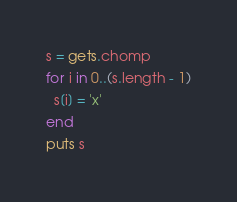Convert code to text. <code><loc_0><loc_0><loc_500><loc_500><_Ruby_>s = gets.chomp
for i in 0..(s.length - 1)
  s[i] = 'x'
end
puts s
</code> 